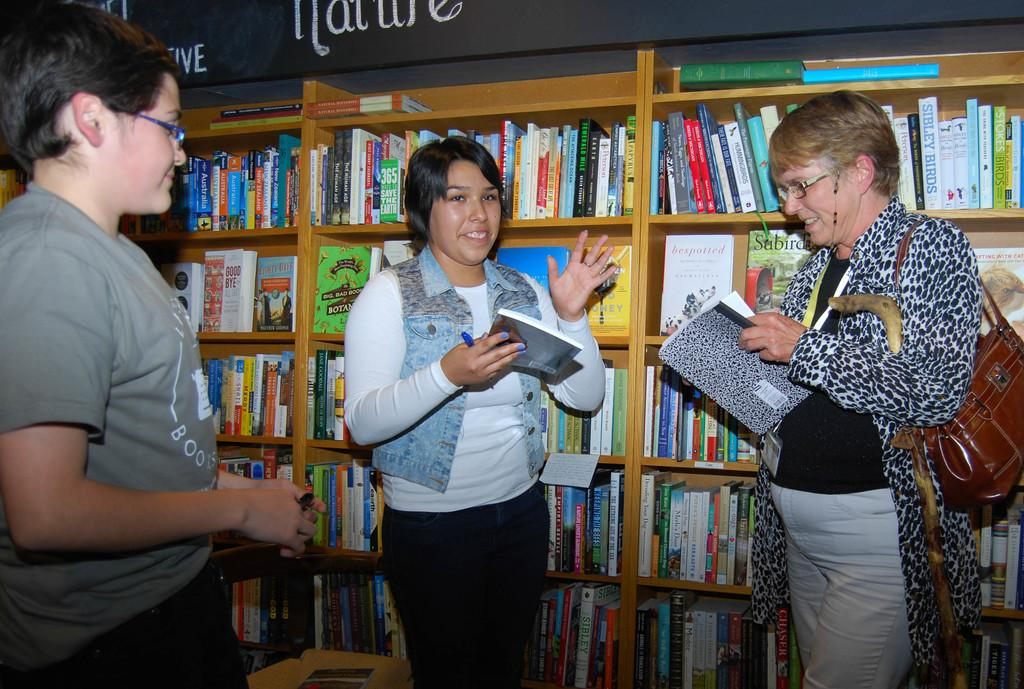Provide a one-sentence caption for the provided image. Three women are talking in a library in the Nature section. 